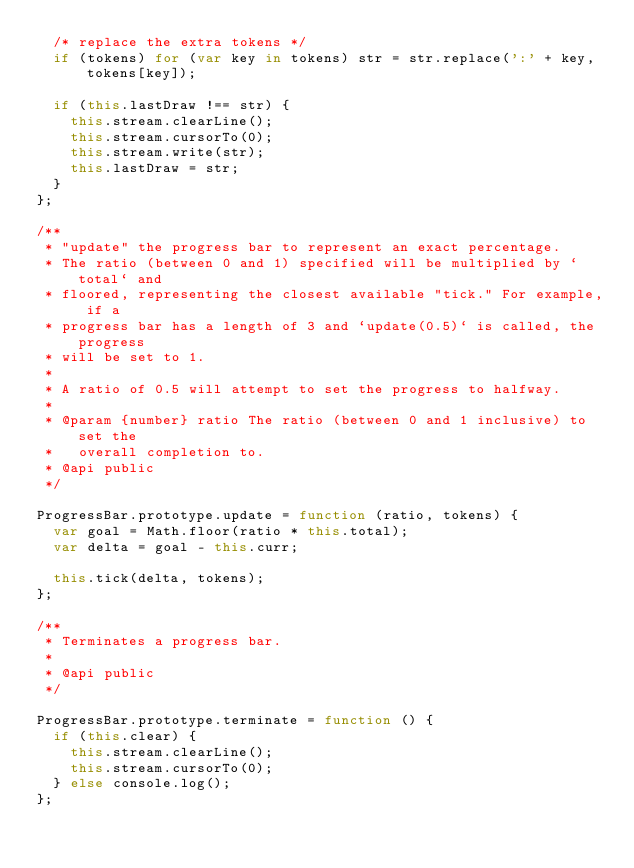Convert code to text. <code><loc_0><loc_0><loc_500><loc_500><_JavaScript_>  /* replace the extra tokens */
  if (tokens) for (var key in tokens) str = str.replace(':' + key, tokens[key]);

  if (this.lastDraw !== str) {
    this.stream.clearLine();
    this.stream.cursorTo(0);
    this.stream.write(str);
    this.lastDraw = str;
  }
};

/**
 * "update" the progress bar to represent an exact percentage.
 * The ratio (between 0 and 1) specified will be multiplied by `total` and
 * floored, representing the closest available "tick." For example, if a
 * progress bar has a length of 3 and `update(0.5)` is called, the progress
 * will be set to 1.
 *
 * A ratio of 0.5 will attempt to set the progress to halfway.
 *
 * @param {number} ratio The ratio (between 0 and 1 inclusive) to set the
 *   overall completion to.
 * @api public
 */

ProgressBar.prototype.update = function (ratio, tokens) {
  var goal = Math.floor(ratio * this.total);
  var delta = goal - this.curr;

  this.tick(delta, tokens);
};

/**
 * Terminates a progress bar.
 *
 * @api public
 */

ProgressBar.prototype.terminate = function () {
  if (this.clear) {
    this.stream.clearLine();
    this.stream.cursorTo(0);
  } else console.log();
};
</code> 